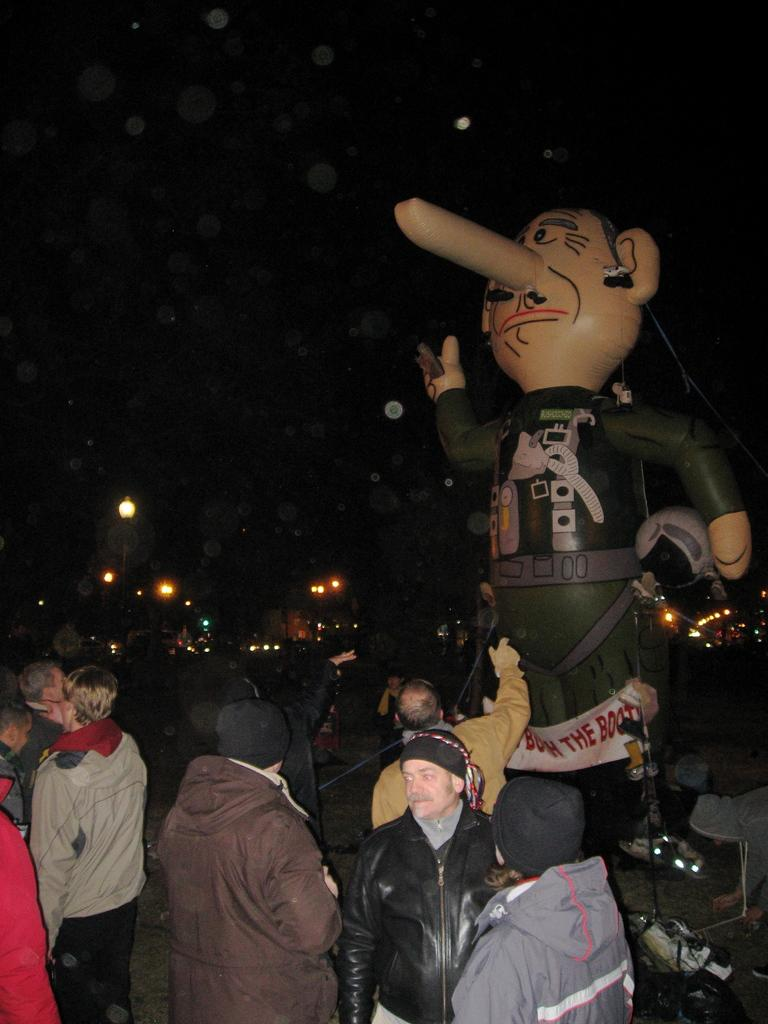What is happening on the road in the image? There are many people standing on the road in the image. What can be seen on the right side of the image? There is a toy statue on the right side of the image. What is visible in the background of the image? There are lights visible in the background of the image. Can you see any planes flying over the seashore in the image? There is no seashore or planes visible in the image; it features people standing on the road and a toy statue on the right side. 